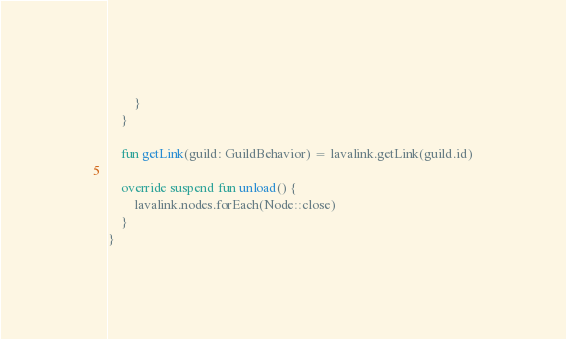Convert code to text. <code><loc_0><loc_0><loc_500><loc_500><_Kotlin_>        }
    }

    fun getLink(guild: GuildBehavior) = lavalink.getLink(guild.id)

    override suspend fun unload() {
        lavalink.nodes.forEach(Node::close)
    }
}
</code> 